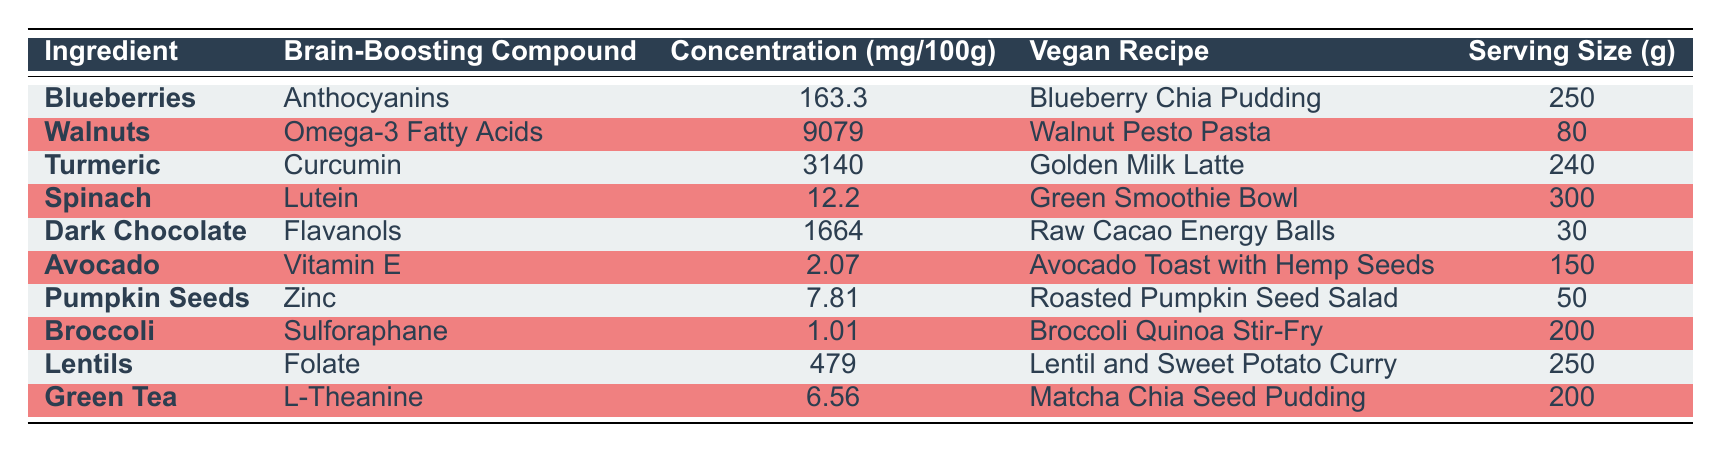What ingredient contains the highest concentration of a brain-boosting compound? The table shows that Walnuts have the highest concentration of Omega-3 Fatty Acids at 9079 mg/100g, more than any other ingredient listed.
Answer: Walnuts Which recipe features Dark Chocolate? The recipe associated with Dark Chocolate in the table is Raw Cacao Energy Balls.
Answer: Raw Cacao Energy Balls Is Spinach listed as having a higher concentration of Lutein than Avocado has for Vitamin E? By comparing the values, Spinach has 12.2 mg/100g for Lutein, while Avocado has 2.07 mg/100g for Vitamin E. Since 12.2 is greater than 2.07, the answer is true.
Answer: Yes What is the total concentration of brain-boosting compounds for Blueberries and Lentils combined? The concentration for Blueberries is 163.3 mg/100g, and for Lentils, it is 479 mg/100g. Adding these values gives 163.3 + 479 = 642.3 mg/100g.
Answer: 642.3 mg/100g Which ingredient has the lowest concentration of a brain-boosting compound? In the table, Broccoli has a concentration of only 1.01 mg/100g for Sulforaphane, which is lower than any other ingredient.
Answer: Broccoli What is the serving size for the Golden Milk Latte recipe? According to the table, the serving size for the Golden Milk Latte recipe, which contains Turmeric, is 240 grams.
Answer: 240 grams Does Green Tea contain more L-Theanine than Pumpkin Seeds have Zinc? Green Tea contains 6.56 mg/100g of L-Theanine, while Pumpkin Seeds have 7.81 mg/100g of Zinc. Since 7.81 is greater than 6.56, the answer is false.
Answer: No What is the average concentration of brain-boosting compounds among the recipes? The concentrations of the compounds are: 163.3, 9079, 3140, 12.2, 1664, 2.07, 7.81, 1.01, 479, and 6.56 mg/100g. Adding these gives 12106.14, and dividing by 10 (the number of ingredients) results in an average of 1210.614 mg/100g.
Answer: 1210.614 mg/100g 